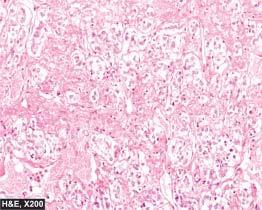re the lipofuscin pigment granules large, polyhedral and pleomorphic having abundant granular cytoplasm?
Answer the question using a single word or phrase. No 